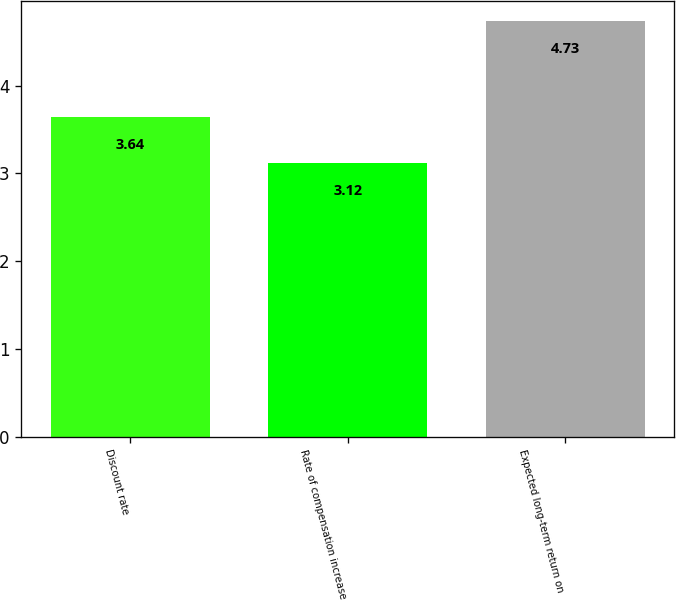Convert chart. <chart><loc_0><loc_0><loc_500><loc_500><bar_chart><fcel>Discount rate<fcel>Rate of compensation increase<fcel>Expected long-term return on<nl><fcel>3.64<fcel>3.12<fcel>4.73<nl></chart> 